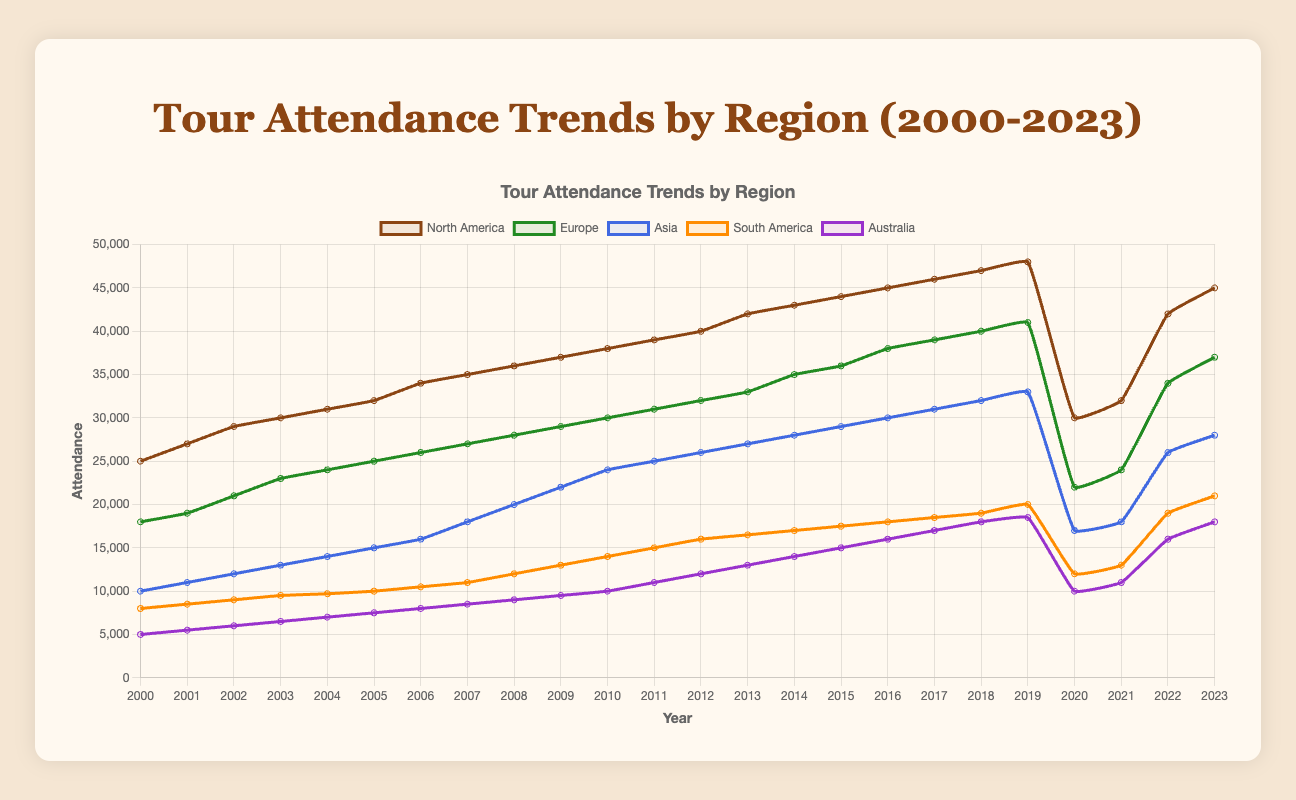Which region had the highest tour attendance in 2023? By examining the line plot for the year 2023, I observe that the line representing North America is the highest among all regions.
Answer: North America How did the attendance in Asia change from 2000 to 2023? To determine this, I subtract the attendance in Asia in 2000 (10,000) from that in 2023 (28,000): 28,000 - 10,000 = 18,000. This gives the change in attendance over the period.
Answer: Increased by 18,000 Which year saw the lowest attendance in Australia and what was the attendance? From the trend lines, I can see that the lowest attendance in Australia appears in 2000, where the attendance was 5,000.
Answer: 2000, 5,000 Compare the tour attendance trends for Europe and North America between 2000 and 2023. Which had a greater overall increase? For North America, subtract 2000 attendance (25,000) from 2023 (45,000): 45,000 - 25,000 = 20,000. For Europe, subtract 2000 attendance (18,000) from 2023 (37,000): 37,000 - 18,000 = 19,000. North America had a greater increase.
Answer: North America What was the total tour attendance across all regions in 2022? Sum the attendance from all regions for 2022: 42,000 (North America) + 34,000 (Europe) + 26,000 (Asia) + 19,000 (South America) + 16,000 (Australia) = 137,000.
Answer: 137,000 Which region had the most significant decline in attendance from 2019 to 2020? From 2019 to 2020, the changes in attendance are: North America (48,000 to 30,000), Europe (41,000 to 22,000), Asia (33,000 to 17,000), South America (20,000 to 12,000), and Australia (18,500 to 10,000). North America had the largest decline (48,000 - 30,000 = 18,000).
Answer: North America Which year had the highest total attendance across all regions combined? Adding up the attendance numbers for all regions across each year, I find that the highest total attendance is in 2019. Summing the 2019 values: 48,000 (North America) + 41,000 (Europe) + 33,000 (Asia) + 20,000 (South America) + 18,500 (Australia) = 160,500.
Answer: 2019 Did South America ever surpass Asia in attendance in any year? By visually comparing the lines for South America and Asia, I notice that Asia always had higher attendance than South America in all years.
Answer: No 